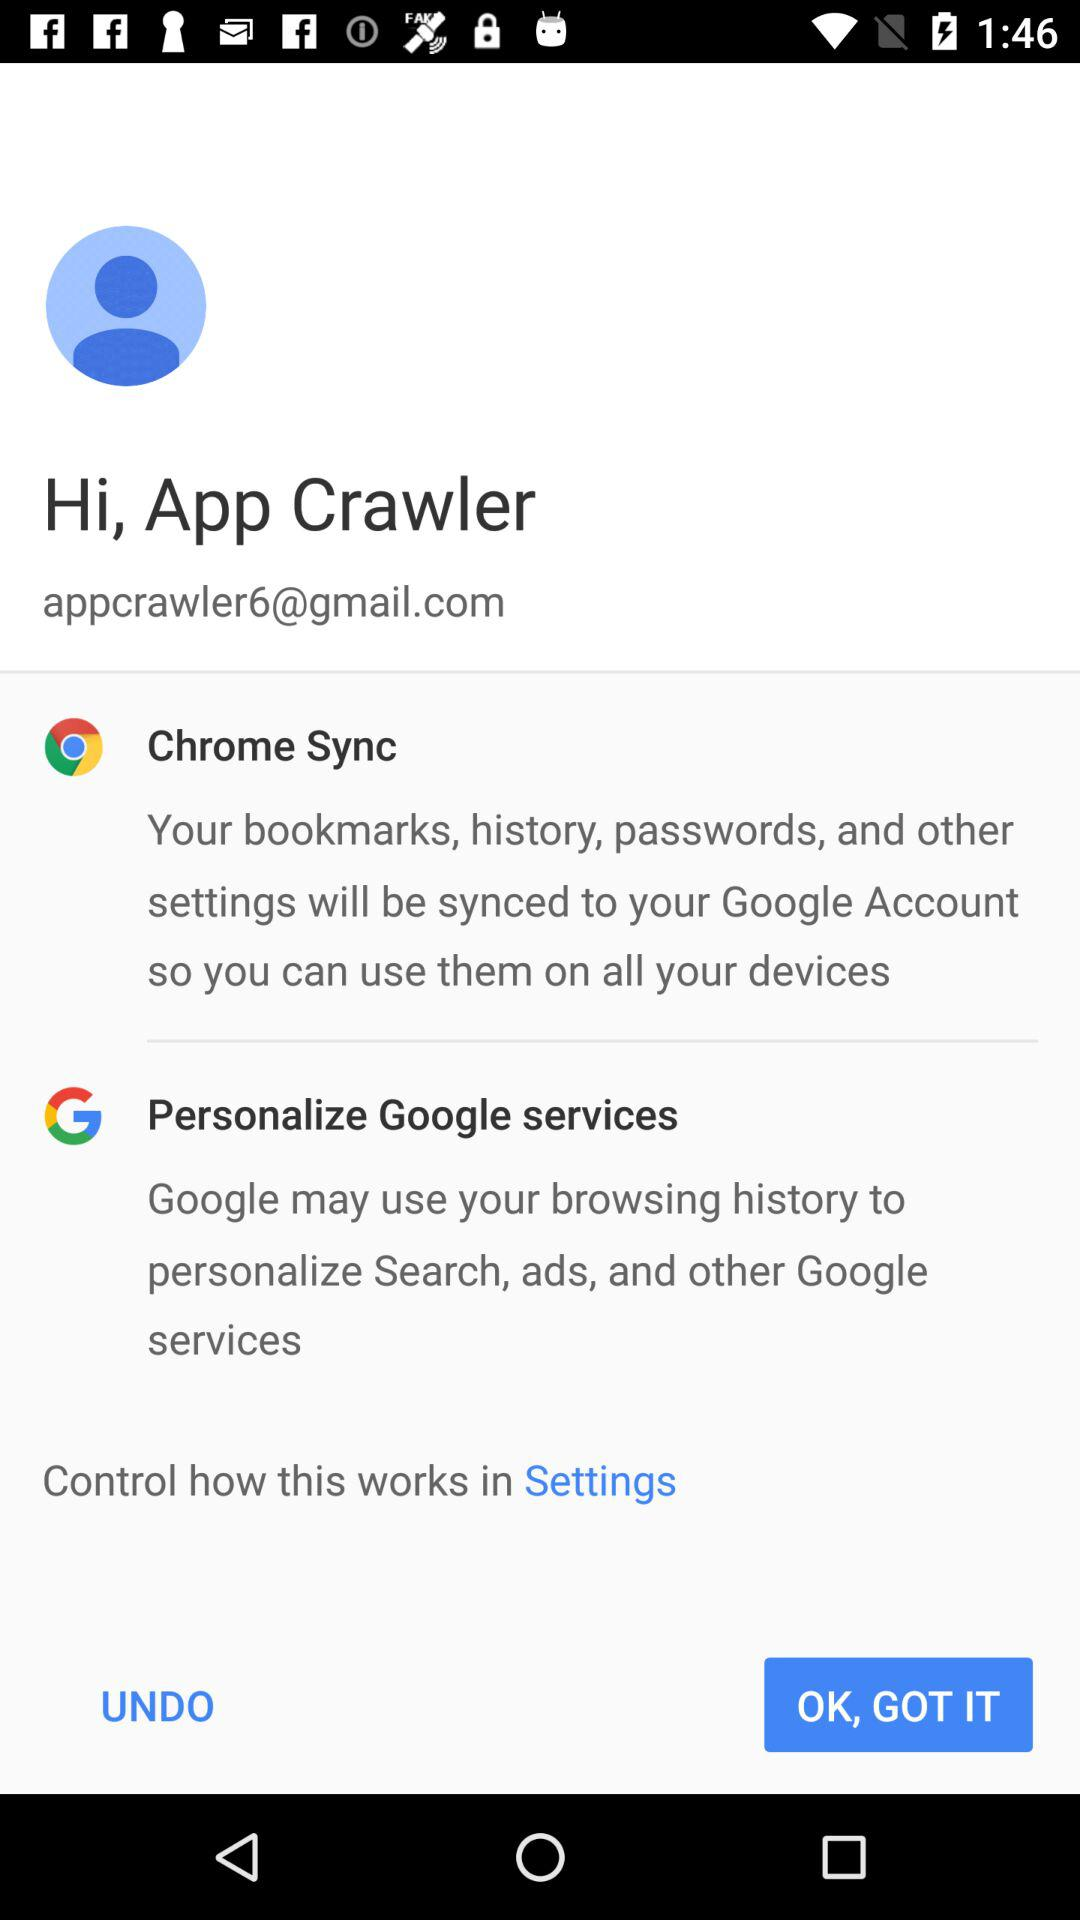What is the mentioned email address? The mentioned email address is appcrawler6@gmail.com. 